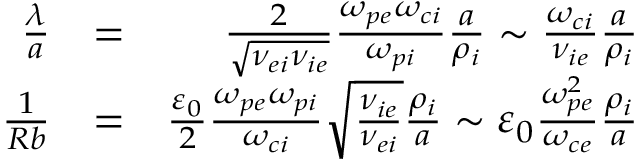Convert formula to latex. <formula><loc_0><loc_0><loc_500><loc_500>\begin{array} { r l r } { \frac { \lambda } { a } } & { = } & { \frac { 2 } { \sqrt { \nu _ { e i } \nu _ { i e } } } \frac { \omega _ { p e } \omega _ { c i } } { \omega _ { p i } } \frac { a } { \rho _ { i } } \sim \frac { \omega _ { c i } } { \nu _ { i e } } \frac { a } { \rho _ { i } } } \\ { \frac { 1 } { R b } } & { = } & { \frac { \varepsilon _ { 0 } } { 2 } \frac { \omega _ { p e } \omega _ { p i } } { \omega _ { c i } } \sqrt { \frac { \nu _ { i e } } { \nu _ { e i } } } \frac { \rho _ { i } } { a } \sim \varepsilon _ { 0 } \frac { \omega _ { p e } ^ { 2 } } { \omega _ { c e } } \frac { \rho _ { i } } { a } } \end{array}</formula> 